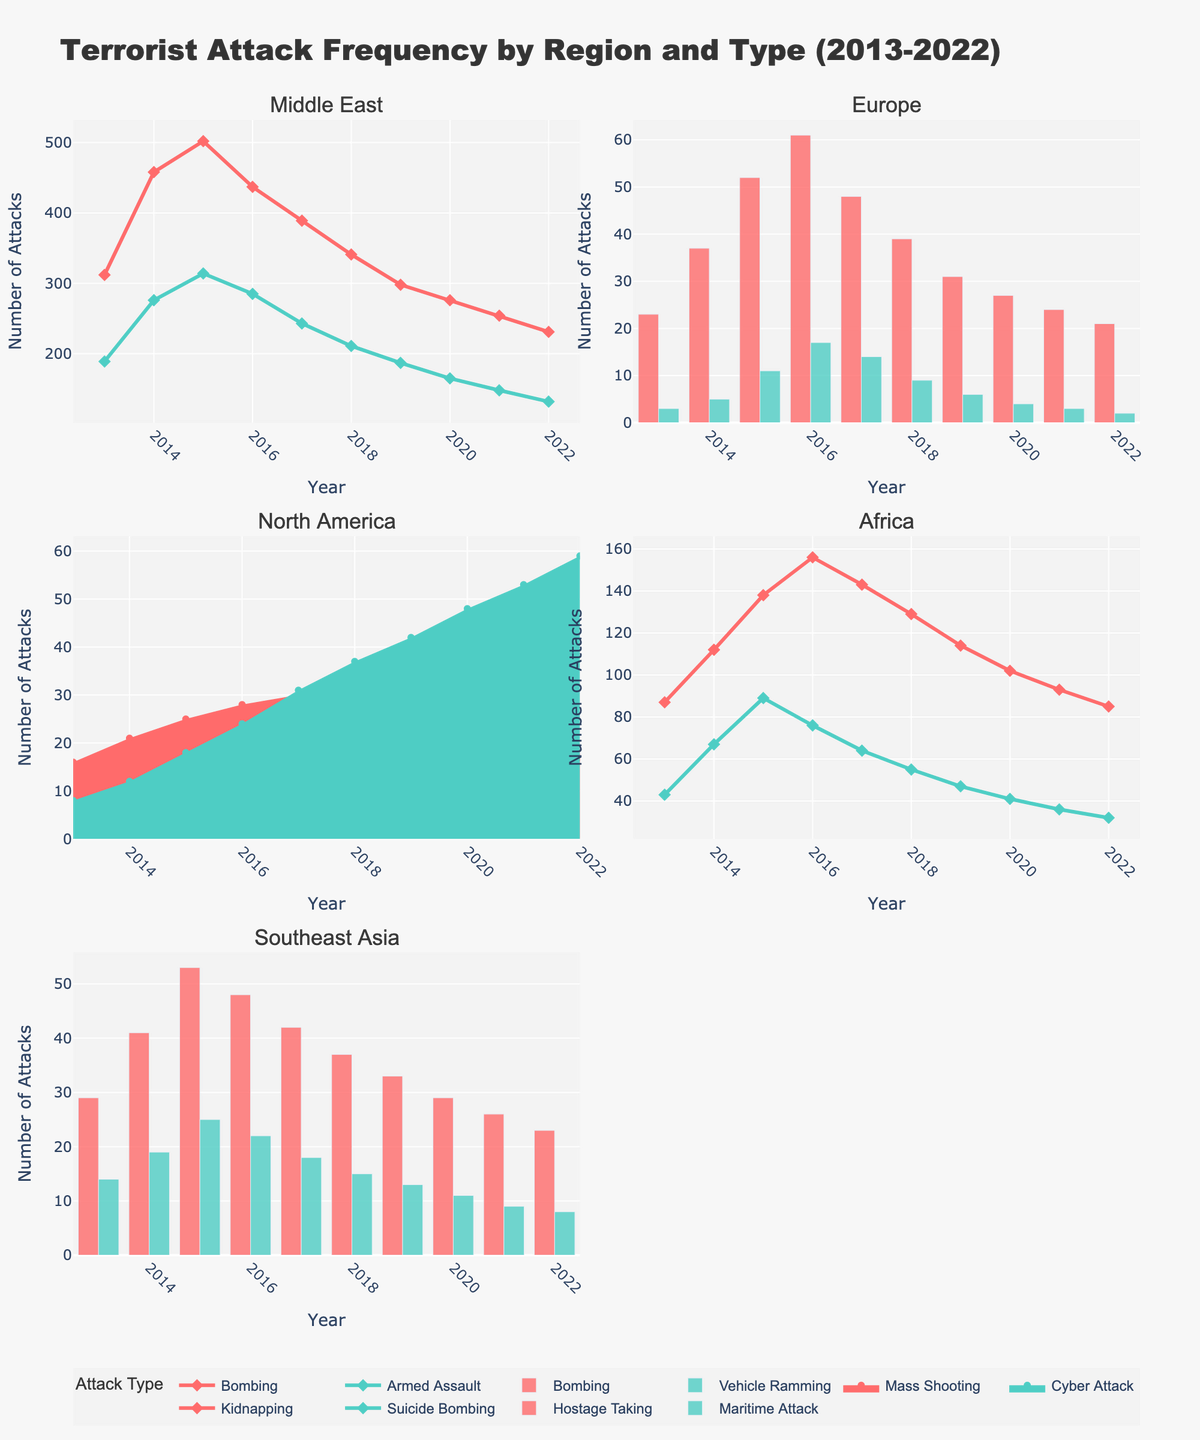what is the title of the figure? The title of a figure is usually found at the top of the chart, it reflects the overall theme or subject being visualized. In this figure, the title is written in a larger font for easy identification.
Answer: Weekly Mood and Adherence to Nutritional Therapy What is the mood rating for week 7? To find the mood rating for week 7, locate week 7 on the horizontal axis of the Mood Rating Over Time subplot, then see where the plot line meets week 7. The corresponding Mood Rating is shown as a marker on the plot line.
Answer: 8 Which week has the highest adherence percentage? The highest adherence percentage can be identified by looking at the tallest bar in the Adherence Percentage Over Time subplot. According to the chart, weeks 7, 8, and 11 all have the highest adherence percentage.
Answer: Week 7, 8, 11 Compare the mood ratings in weeks 4 and 10. Which has a higher rating? To compare the mood ratings, look at the Mood Rating Over Time subplot. Locate weeks 4 and 10 on the horizontal axis and check the corresponding mood ratings on the vertical axis. Week 4's mood rating is 7, while week 10's is 9.
Answer: Week 10 Calculate the average adherence percentage over the 12 weeks. Sum up all the adherence percentages and then divide by the number of weeks to get the average. (60 + 75 + 80 + 90 + 95 + 85 + 100 + 100 + 90 + 95 + 100 + 85) / 12 = 90.42
Answer: 90.42 How does the mood rating trend change over the weeks? Observing the trend in the Mood Rating Over Time subplot, the mood rating generally increases from week 1 to week 8, then fluctuates between 8 and 9 from weeks 9 to 12. This indicates an initial improvement with small variations later.
Answer: Increases initially, then fluctuates Is there a week where both mood rating and adherence percentage decreased compared to the previous week? Compare week-to-week data for both metrics. From weeks 9 to 10, both mood rating and adherence percentage increase, but between weeks 10 and 12, adherence percentage decreases from 100% to 85%, while mood rating decreases only in week 12 from weeks 11.
Answer: Week 12 What is the adherence percentage for week 3? Refer to the Adherence Percentage Over Time subplot and locate week 3 on the horizontal axis. The height of the bar at week 3 shows the adherence percentage value.
Answer: 80 What does the annotation say? Annotations often provide additional context or emphasis. The annotation on this figure is located above the subplots and highlights the theme of the visual data.
Answer: My Journey with Nutritional Therapy 